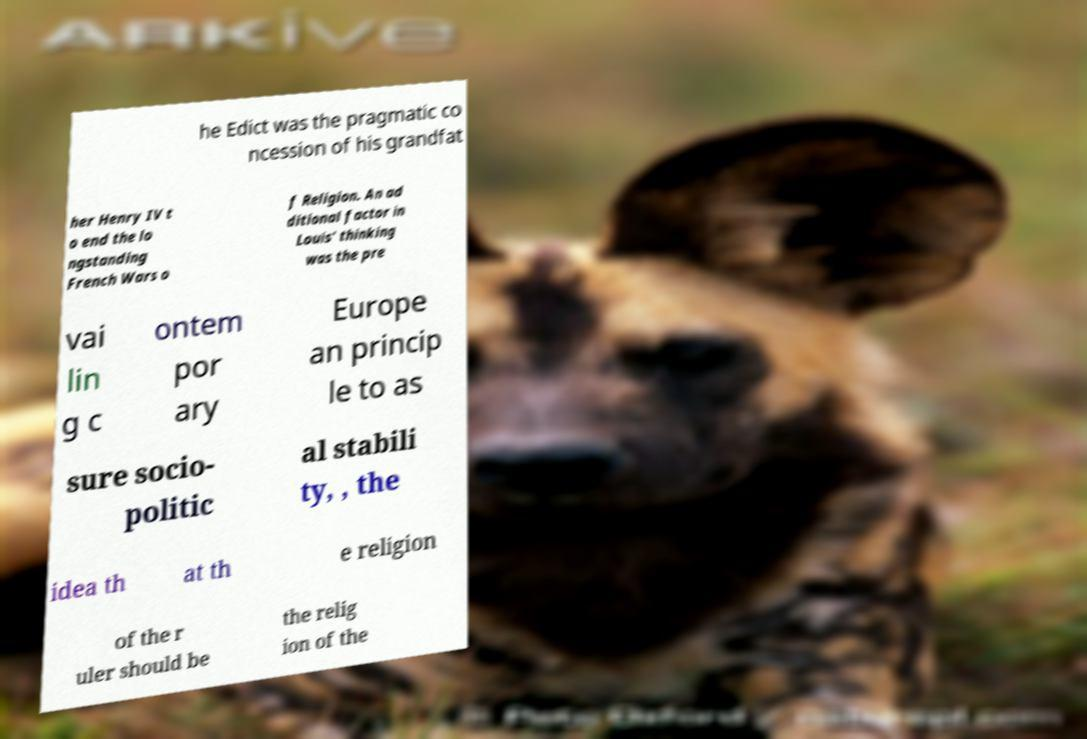Can you read and provide the text displayed in the image?This photo seems to have some interesting text. Can you extract and type it out for me? he Edict was the pragmatic co ncession of his grandfat her Henry IV t o end the lo ngstanding French Wars o f Religion. An ad ditional factor in Louis' thinking was the pre vai lin g c ontem por ary Europe an princip le to as sure socio- politic al stabili ty, , the idea th at th e religion of the r uler should be the relig ion of the 